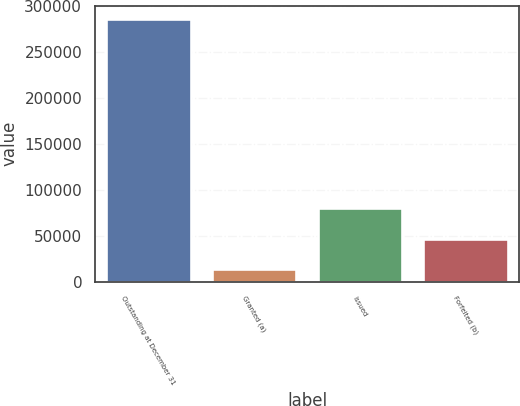Convert chart. <chart><loc_0><loc_0><loc_500><loc_500><bar_chart><fcel>Outstanding at December 31<fcel>Granted (a)<fcel>Issued<fcel>Forfeited (b)<nl><fcel>286499<fcel>14000<fcel>80019.6<fcel>47009.8<nl></chart> 